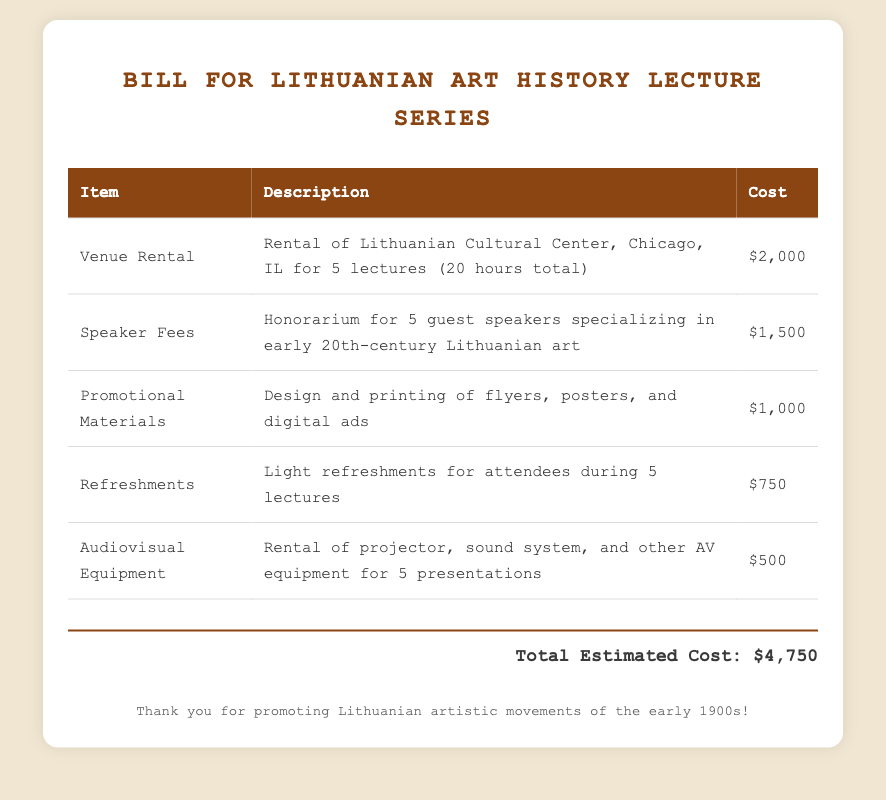What is the total estimated cost? The total estimated cost is stated clearly at the bottom of the bill.
Answer: $4,750 How many guest speakers will be invited? The document specifies that 5 guest speakers will provide their expertise.
Answer: 5 What is the cost of the audiovisual equipment rental? The cost for renting audiovisual equipment is listed in the table.
Answer: $500 Where is the venue for the lectures located? The document mentions the location of the venue in the description of the venue rental.
Answer: Chicago, IL What type of refreshments are provided? The description of refreshments indicates they are light refreshments for attendees.
Answer: Light refreshments What is the specific purpose of the promotional materials? The document describes the nature of the promotional materials in connection with the lectures.
Answer: Design and printing of flyers, posters, and digital ads What is the duration of the venue rental for lectures? The total hours for the venue rental is specified in the document.
Answer: 20 hours What is the honorarium for the guest speakers? The cost related to the speaker fees is clearly mentioned in the table.
Answer: $1,500 